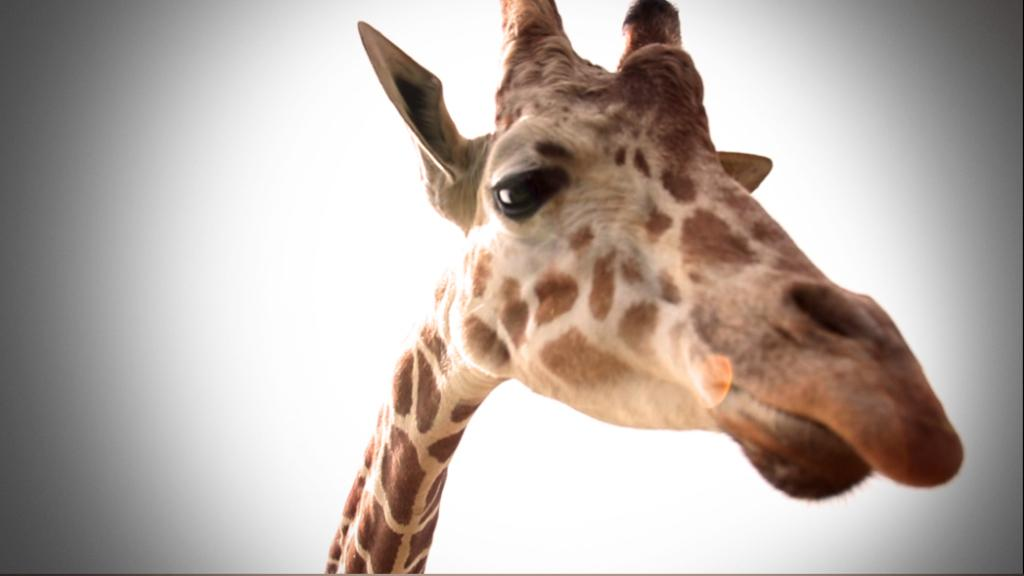What is the main subject of the image? The main subject of the image is a giraffe's neck. Can you describe the location of the giraffe's neck in the image? The giraffe's neck is in the center of the image. What letter is the giraffe holding in the image? There is no letter present in the image, as it features a giraffe's neck. What type of bag is the giraffe carrying in the image? There is no bag present in the image, as it features a giraffe's neck. 